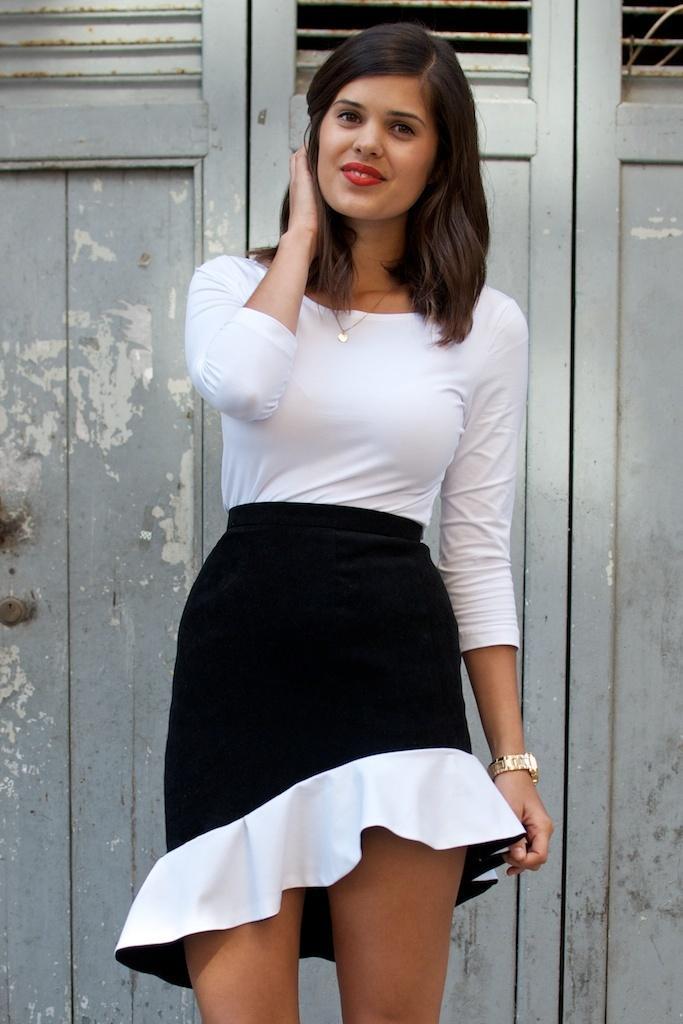Please provide a concise description of this image. In the center of the image we can see a lady standing and smiling. In the background there is a door. 